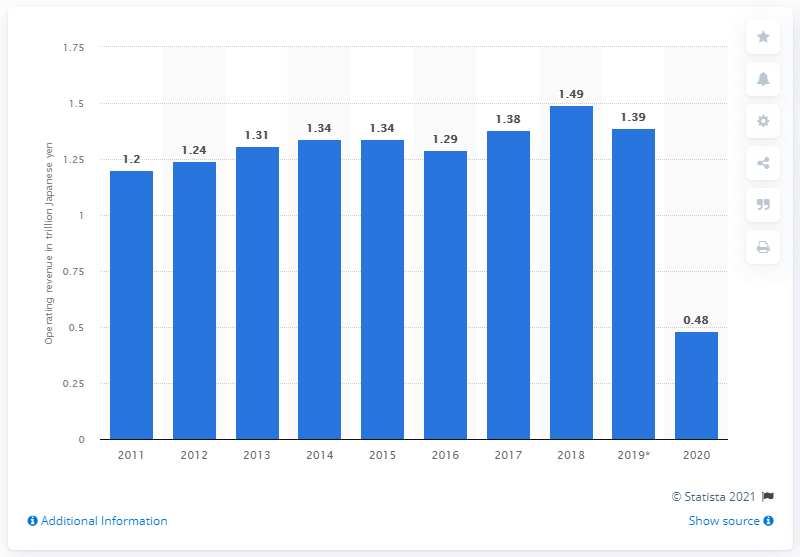Identify some key points in this picture. The revenue of Japan Airlines Co, Ltd. in the previous fiscal year was 1.39 trillion yen. Japan Airlines Co., Ltd. reported a revenue of ¥480 billion in the fiscal year 2020. 